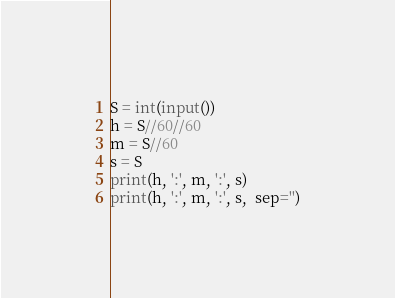Convert code to text. <code><loc_0><loc_0><loc_500><loc_500><_Python_>S = int(input())
h = S//60//60
m = S//60
s = S
print(h, ':', m, ':', s)
print(h, ':', m, ':', s,  sep='')

</code> 